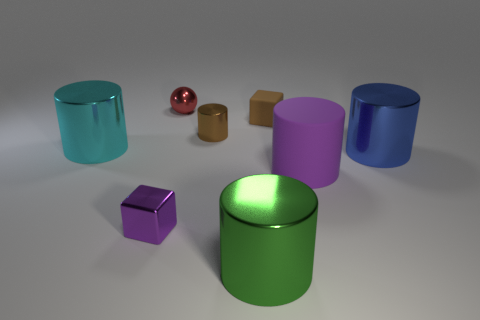There is a blue shiny object that is the same shape as the cyan metal thing; what size is it?
Provide a short and direct response. Large. What number of metal cylinders are in front of the purple thing to the right of the object behind the tiny brown rubber thing?
Ensure brevity in your answer.  1. How many blocks are cyan things or large green rubber objects?
Your answer should be compact. 0. There is a big metal thing on the left side of the small metal object in front of the shiny cylinder to the left of the red metal sphere; what color is it?
Offer a terse response. Cyan. What number of other things are the same size as the purple cube?
Provide a succinct answer. 3. Are there any other things that have the same shape as the small purple object?
Make the answer very short. Yes. The small object that is the same shape as the large purple thing is what color?
Offer a very short reply. Brown. There is a small block that is made of the same material as the tiny cylinder; what is its color?
Provide a short and direct response. Purple. Is the number of cyan cylinders that are in front of the purple matte object the same as the number of tiny purple metal things?
Your response must be concise. No. There is a brown object in front of the brown matte object; is its size the same as the small shiny block?
Provide a succinct answer. Yes. 